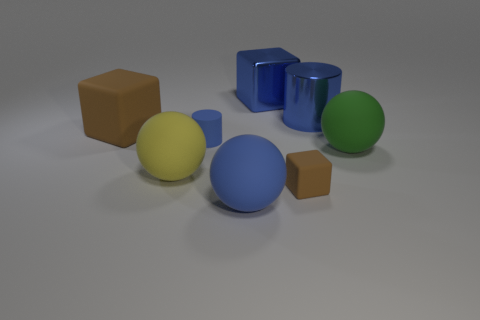Is there a big yellow object made of the same material as the large brown thing?
Provide a succinct answer. Yes. Are there any big brown blocks behind the small matte thing that is on the right side of the blue rubber ball?
Your answer should be compact. Yes. There is a brown rubber block that is in front of the green object; is it the same size as the yellow sphere?
Your response must be concise. No. The blue cube has what size?
Provide a succinct answer. Large. Are there any other matte cylinders that have the same color as the matte cylinder?
Keep it short and to the point. No. What number of big things are blue metal cylinders or yellow cylinders?
Your response must be concise. 1. What is the size of the object that is both in front of the yellow matte object and to the right of the large blue sphere?
Provide a succinct answer. Small. There is a large blue matte thing; what number of rubber spheres are behind it?
Your answer should be compact. 2. What shape is the big rubber object that is both right of the yellow ball and behind the tiny brown object?
Your answer should be very brief. Sphere. There is a large cylinder that is the same color as the tiny cylinder; what is it made of?
Keep it short and to the point. Metal. 